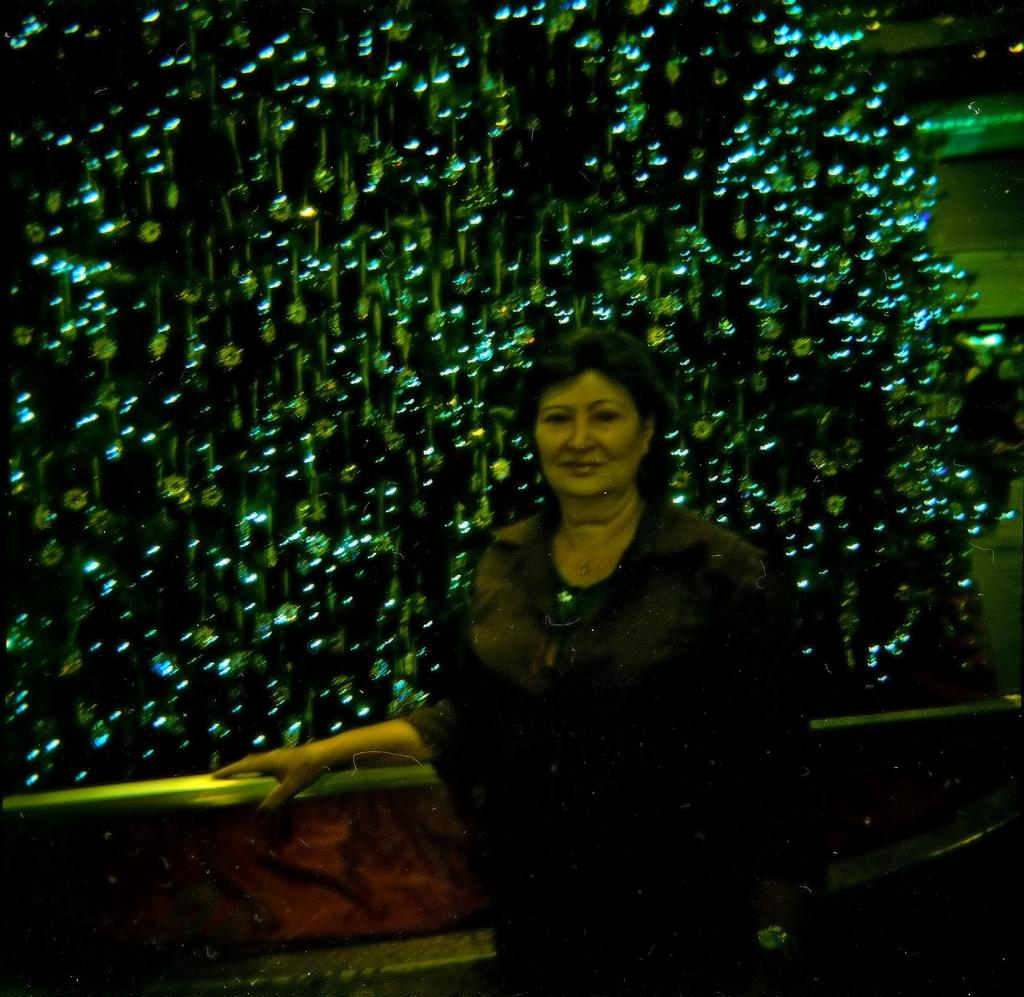Who is the main subject in the image? There is a woman standing in the center of the image. What can be seen in the background of the image? There are lights, poles, and a wall in the background of the image. What type of boot is the doll wearing in the image? There is no doll present in the image, so it is not possible to determine what type of boot the doll might be wearing. 